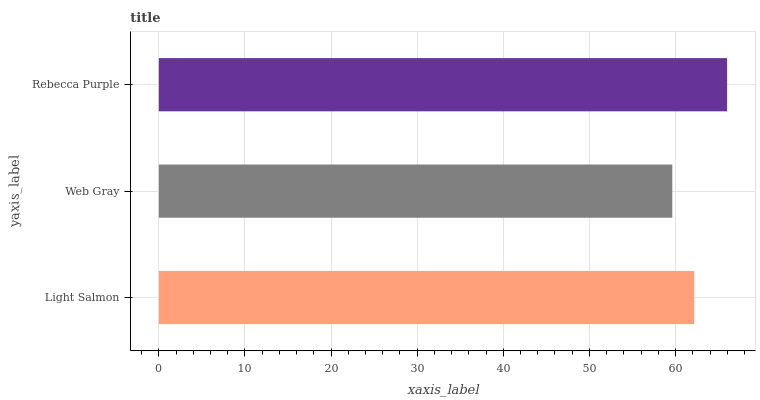Is Web Gray the minimum?
Answer yes or no. Yes. Is Rebecca Purple the maximum?
Answer yes or no. Yes. Is Rebecca Purple the minimum?
Answer yes or no. No. Is Web Gray the maximum?
Answer yes or no. No. Is Rebecca Purple greater than Web Gray?
Answer yes or no. Yes. Is Web Gray less than Rebecca Purple?
Answer yes or no. Yes. Is Web Gray greater than Rebecca Purple?
Answer yes or no. No. Is Rebecca Purple less than Web Gray?
Answer yes or no. No. Is Light Salmon the high median?
Answer yes or no. Yes. Is Light Salmon the low median?
Answer yes or no. Yes. Is Rebecca Purple the high median?
Answer yes or no. No. Is Rebecca Purple the low median?
Answer yes or no. No. 